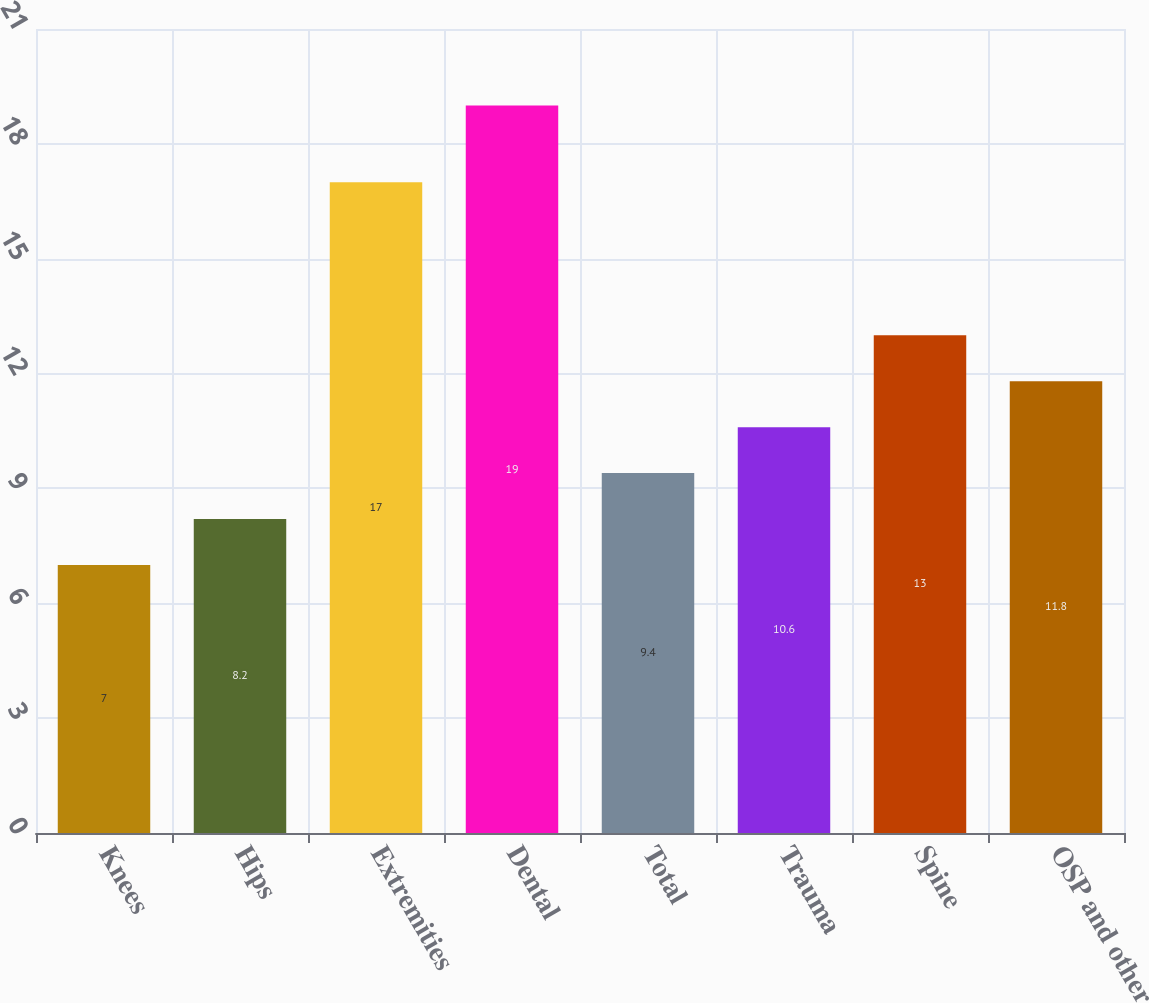Convert chart to OTSL. <chart><loc_0><loc_0><loc_500><loc_500><bar_chart><fcel>Knees<fcel>Hips<fcel>Extremities<fcel>Dental<fcel>Total<fcel>Trauma<fcel>Spine<fcel>OSP and other<nl><fcel>7<fcel>8.2<fcel>17<fcel>19<fcel>9.4<fcel>10.6<fcel>13<fcel>11.8<nl></chart> 